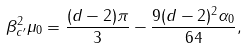Convert formula to latex. <formula><loc_0><loc_0><loc_500><loc_500>\beta _ { c ^ { \prime } } ^ { 2 } \mu _ { 0 } = \frac { ( d - 2 ) \pi } { 3 } - \frac { 9 ( d - 2 ) ^ { 2 } \alpha _ { 0 } } { 6 4 } ,</formula> 